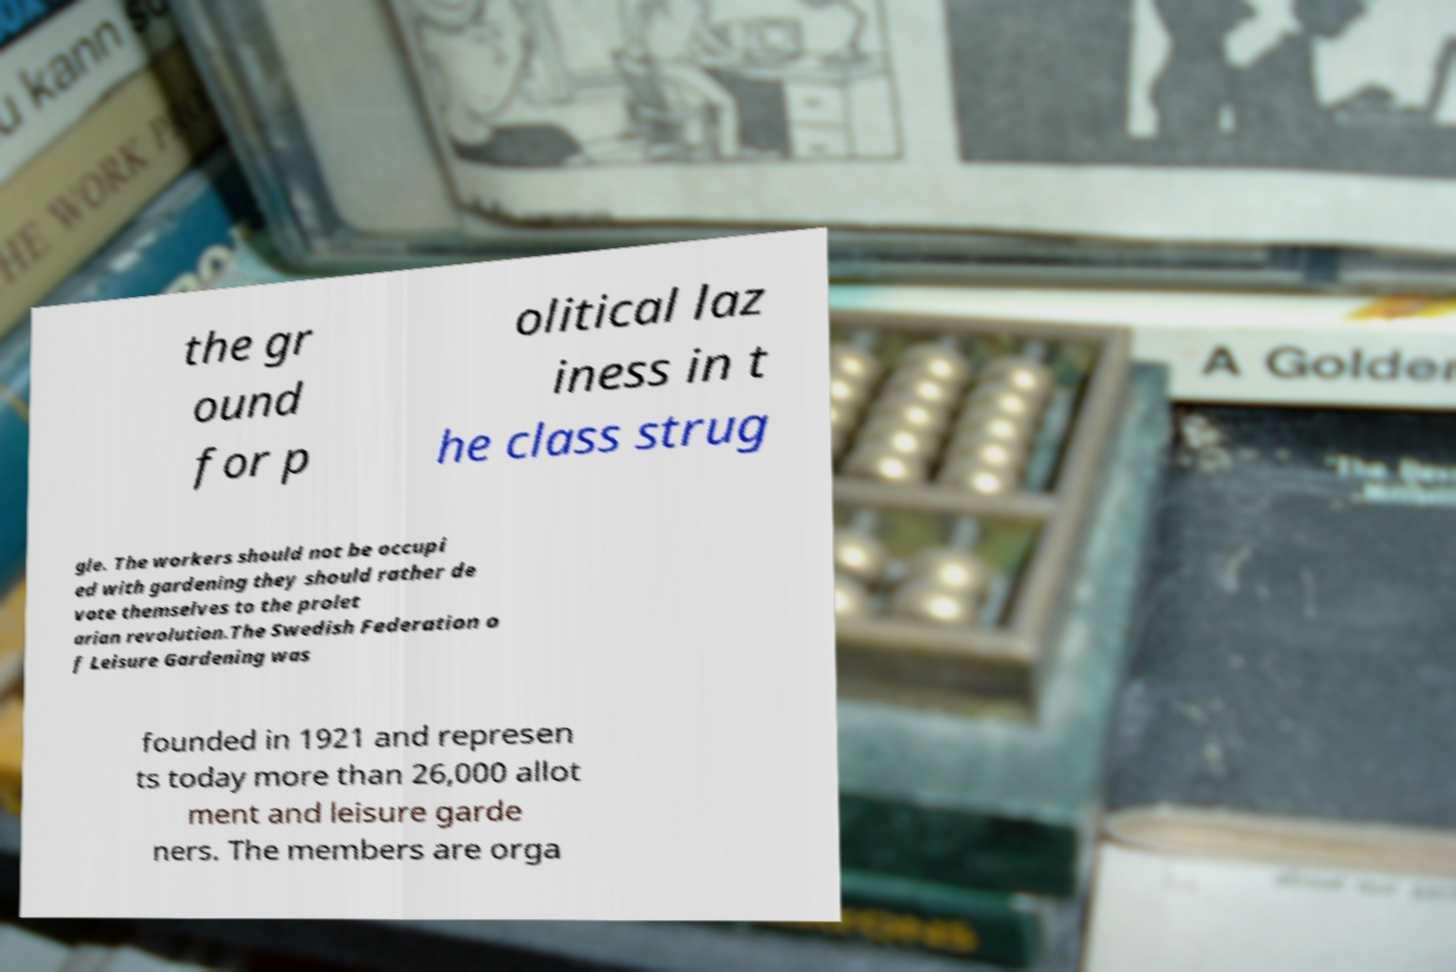I need the written content from this picture converted into text. Can you do that? the gr ound for p olitical laz iness in t he class strug gle. The workers should not be occupi ed with gardening they should rather de vote themselves to the prolet arian revolution.The Swedish Federation o f Leisure Gardening was founded in 1921 and represen ts today more than 26,000 allot ment and leisure garde ners. The members are orga 